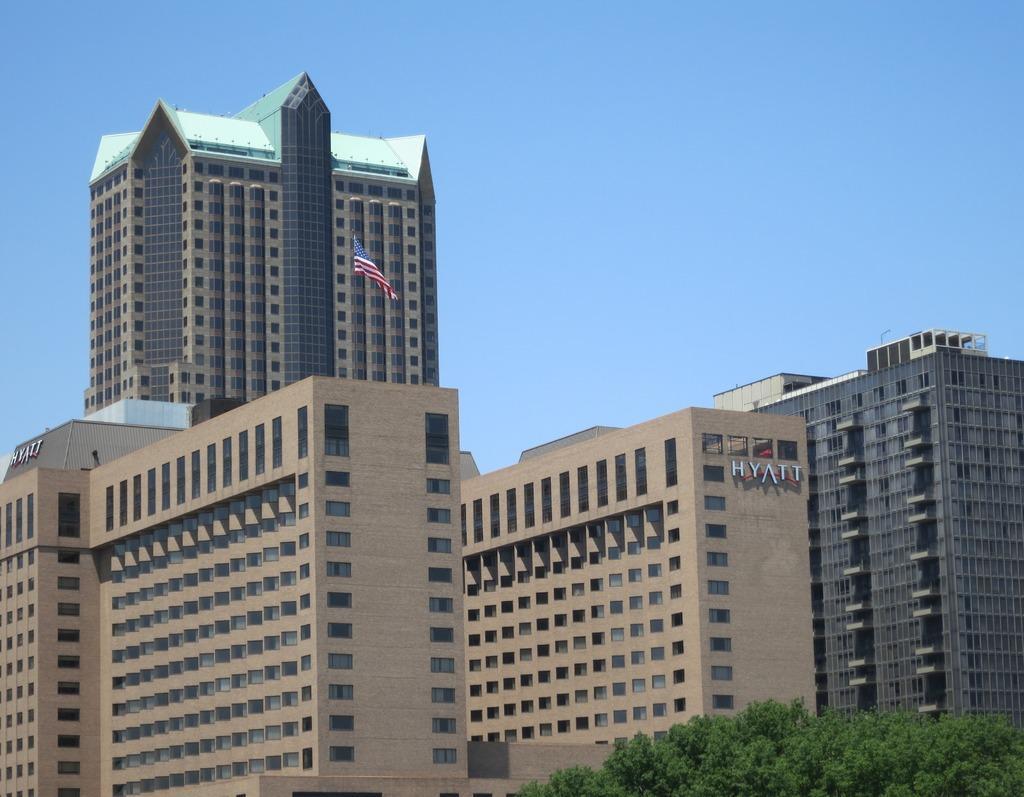In one or two sentences, can you explain what this image depicts? In this picture we can see buildings, there is a flag in the middle, at the right bottom there are trees, we can see the sky at the top of the picture. 